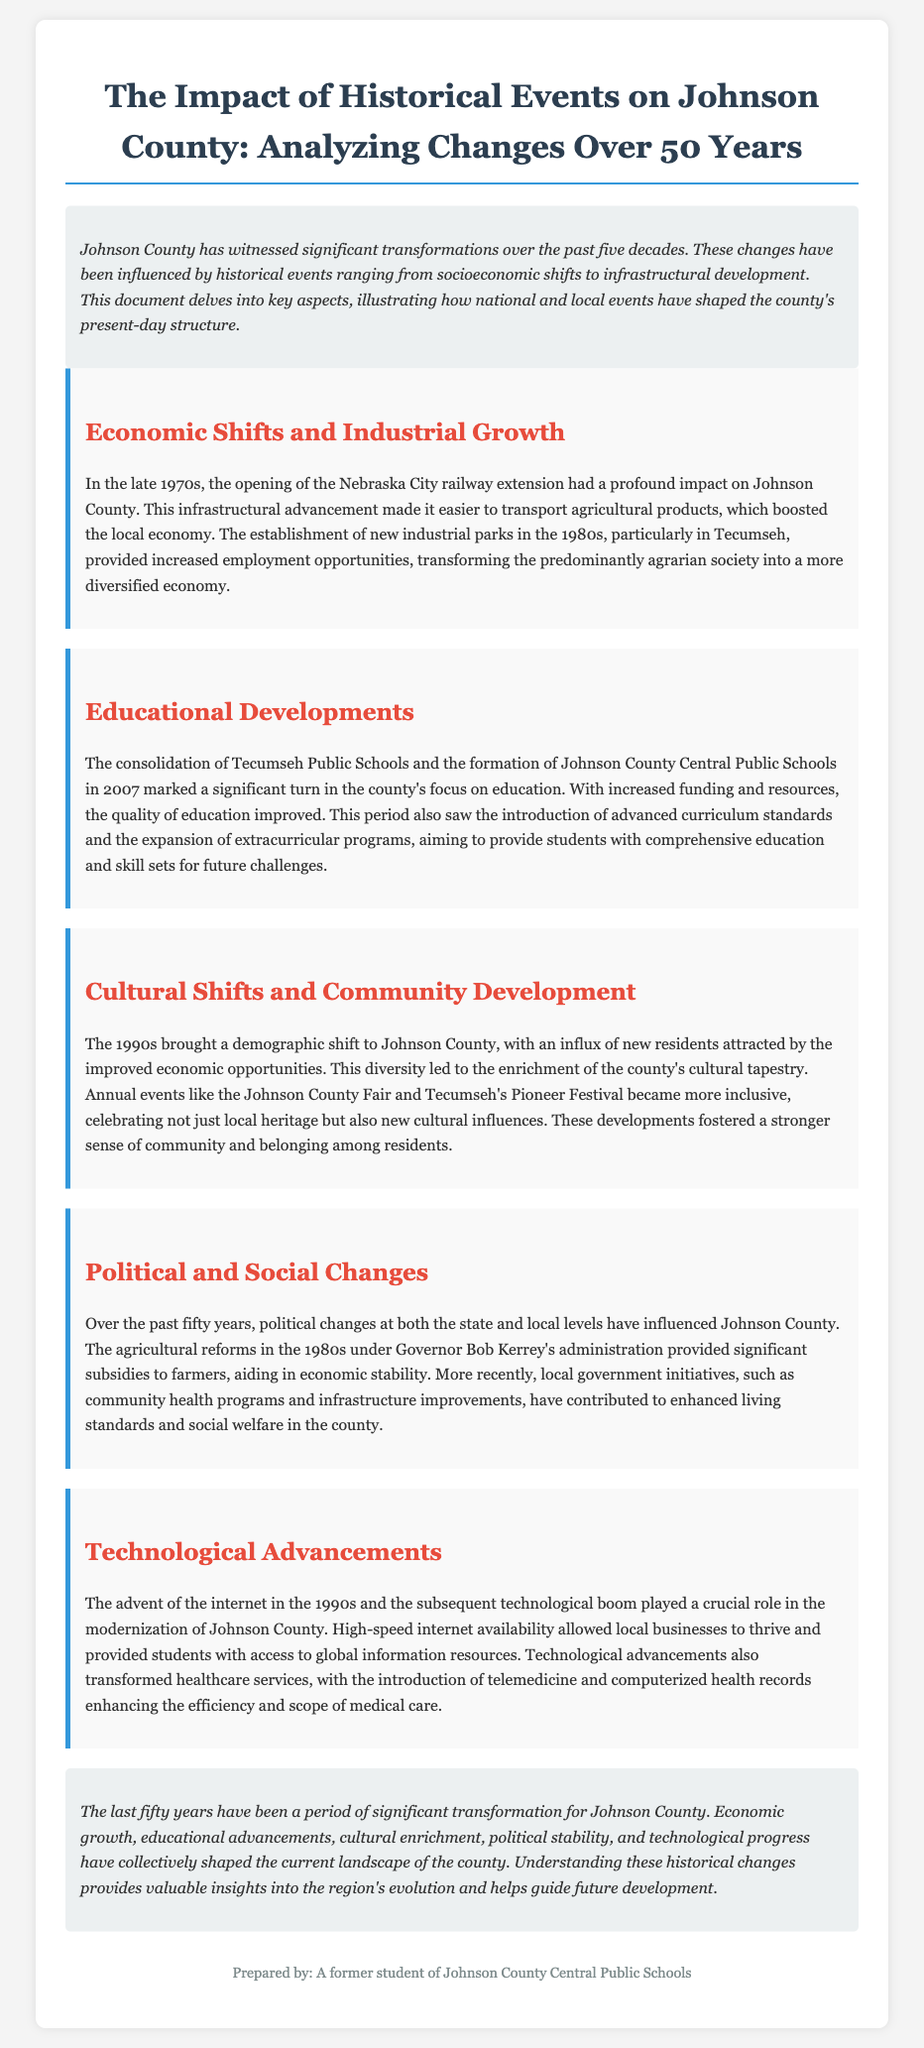What significant infrastructural development occurred in the late 1970s? The document states that the opening of the Nebraska City railway extension had a profound impact on Johnson County.
Answer: Nebraska City railway extension When was Johnson County Central Public Schools formed? The document mentions that the formation of Johnson County Central Public Schools took place in 2007.
Answer: 2007 What was a major cultural event mentioned in the document? The document highlights the Johnson County Fair as an annual event that became more inclusive.
Answer: Johnson County Fair What economic shift happened due to industrial parks in the 1980s? The establishment of new industrial parks in Tecumseh provided increased employment opportunities, transforming the economy.
Answer: Increased employment opportunities Who was the governor during the agricultural reforms in the 1980s? The document names Governor Bob Kerrey's administration as the period of the agricultural reforms.
Answer: Bob Kerrey What technological advancement in the 1990s significantly impacted Johnson County? The document states that the advent of the internet in the 1990s played a crucial role in modernization.
Answer: Internet How did consolidation in education affect Johnson County? The consolidation marked a significant turn in the county's focus on education with improved quality and funding.
Answer: Improved quality of education What year marked the demographic shift mentioned in the document? The demographic shift to Johnson County occurred in the 1990s.
Answer: 1990s 